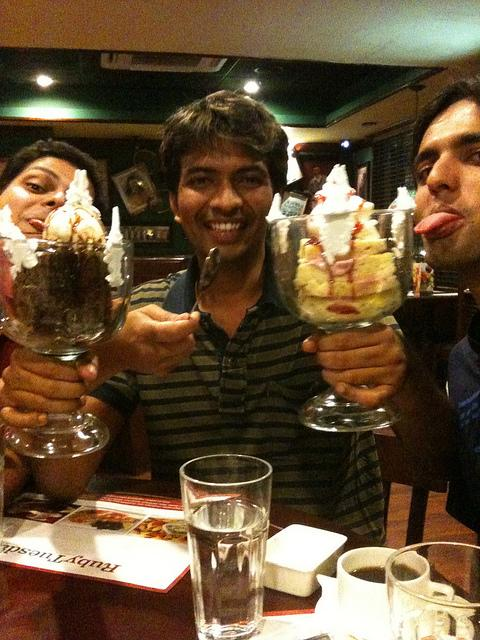In what year did this company exit bankruptcy? 2021 